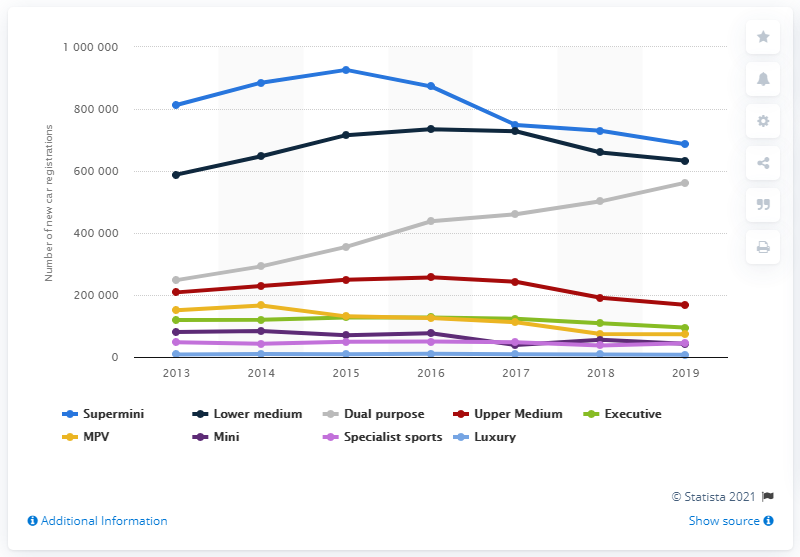Indicate a few pertinent items in this graphic. The number of passenger car registrations in the UK began to increase in the year 2013. 